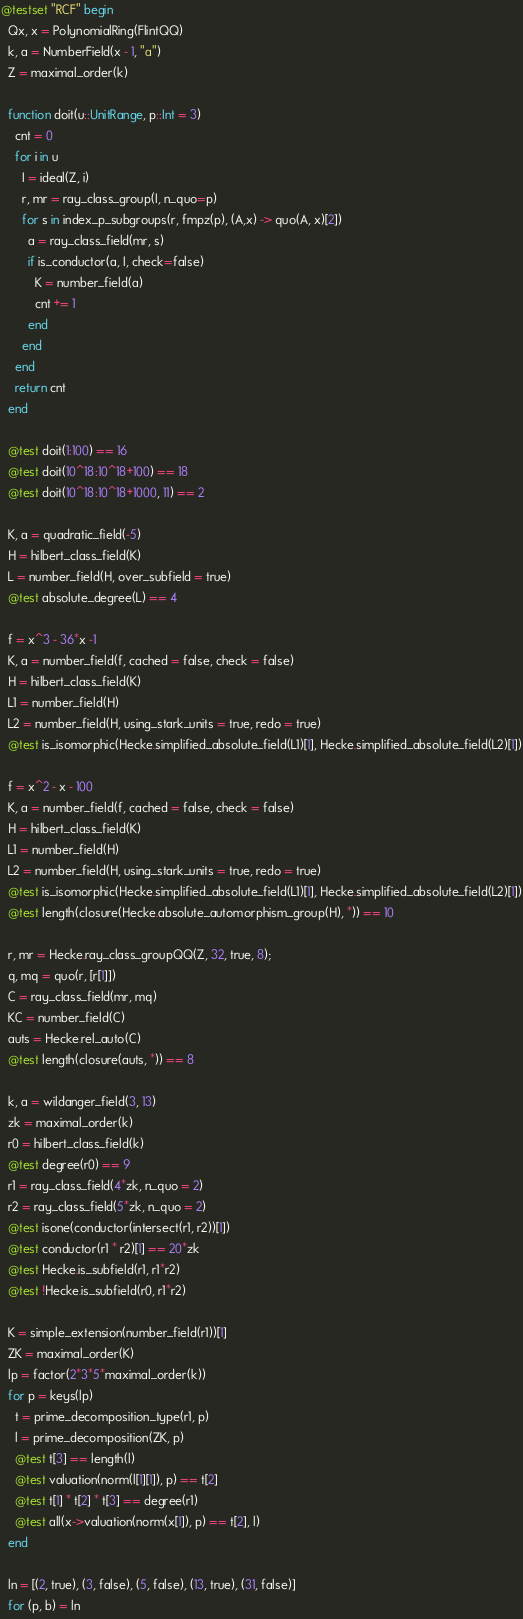<code> <loc_0><loc_0><loc_500><loc_500><_Julia_>@testset "RCF" begin
  Qx, x = PolynomialRing(FlintQQ)
  k, a = NumberField(x - 1, "a")
  Z = maximal_order(k)

  function doit(u::UnitRange, p::Int = 3)
    cnt = 0
    for i in u
      I = ideal(Z, i)
      r, mr = ray_class_group(I, n_quo=p)
      for s in index_p_subgroups(r, fmpz(p), (A,x) -> quo(A, x)[2])
        a = ray_class_field(mr, s)
        if is_conductor(a, I, check=false)
          K = number_field(a)
          cnt += 1
        end
      end
    end
    return cnt
  end

  @test doit(1:100) == 16
  @test doit(10^18:10^18+100) == 18
  @test doit(10^18:10^18+1000, 11) == 2

  K, a = quadratic_field(-5)
  H = hilbert_class_field(K)
  L = number_field(H, over_subfield = true)
  @test absolute_degree(L) == 4

  f = x^3 - 36*x -1
  K, a = number_field(f, cached = false, check = false)
  H = hilbert_class_field(K)
  L1 = number_field(H)
  L2 = number_field(H, using_stark_units = true, redo = true)
  @test is_isomorphic(Hecke.simplified_absolute_field(L1)[1], Hecke.simplified_absolute_field(L2)[1])

  f = x^2 - x - 100
  K, a = number_field(f, cached = false, check = false)
  H = hilbert_class_field(K)
  L1 = number_field(H)
  L2 = number_field(H, using_stark_units = true, redo = true)
  @test is_isomorphic(Hecke.simplified_absolute_field(L1)[1], Hecke.simplified_absolute_field(L2)[1])
  @test length(closure(Hecke.absolute_automorphism_group(H), *)) == 10

  r, mr = Hecke.ray_class_groupQQ(Z, 32, true, 8);
  q, mq = quo(r, [r[1]])
  C = ray_class_field(mr, mq)
  KC = number_field(C)
  auts = Hecke.rel_auto(C)
  @test length(closure(auts, *)) == 8

  k, a = wildanger_field(3, 13)
  zk = maximal_order(k)
  r0 = hilbert_class_field(k)
  @test degree(r0) == 9
  r1 = ray_class_field(4*zk, n_quo = 2)
  r2 = ray_class_field(5*zk, n_quo = 2)
  @test isone(conductor(intersect(r1, r2))[1])
  @test conductor(r1 * r2)[1] == 20*zk
  @test Hecke.is_subfield(r1, r1*r2)
  @test !Hecke.is_subfield(r0, r1*r2)

  K = simple_extension(number_field(r1))[1]
  ZK = maximal_order(K)
  lp = factor(2*3*5*maximal_order(k))
  for p = keys(lp)
    t = prime_decomposition_type(r1, p)
    l = prime_decomposition(ZK, p)
    @test t[3] == length(l)
    @test valuation(norm(l[1][1]), p) == t[2]
    @test t[1] * t[2] * t[3] == degree(r1)
    @test all(x->valuation(norm(x[1]), p) == t[2], l)
  end

  ln = [(2, true), (3, false), (5, false), (13, true), (31, false)]
  for (p, b) = ln</code> 